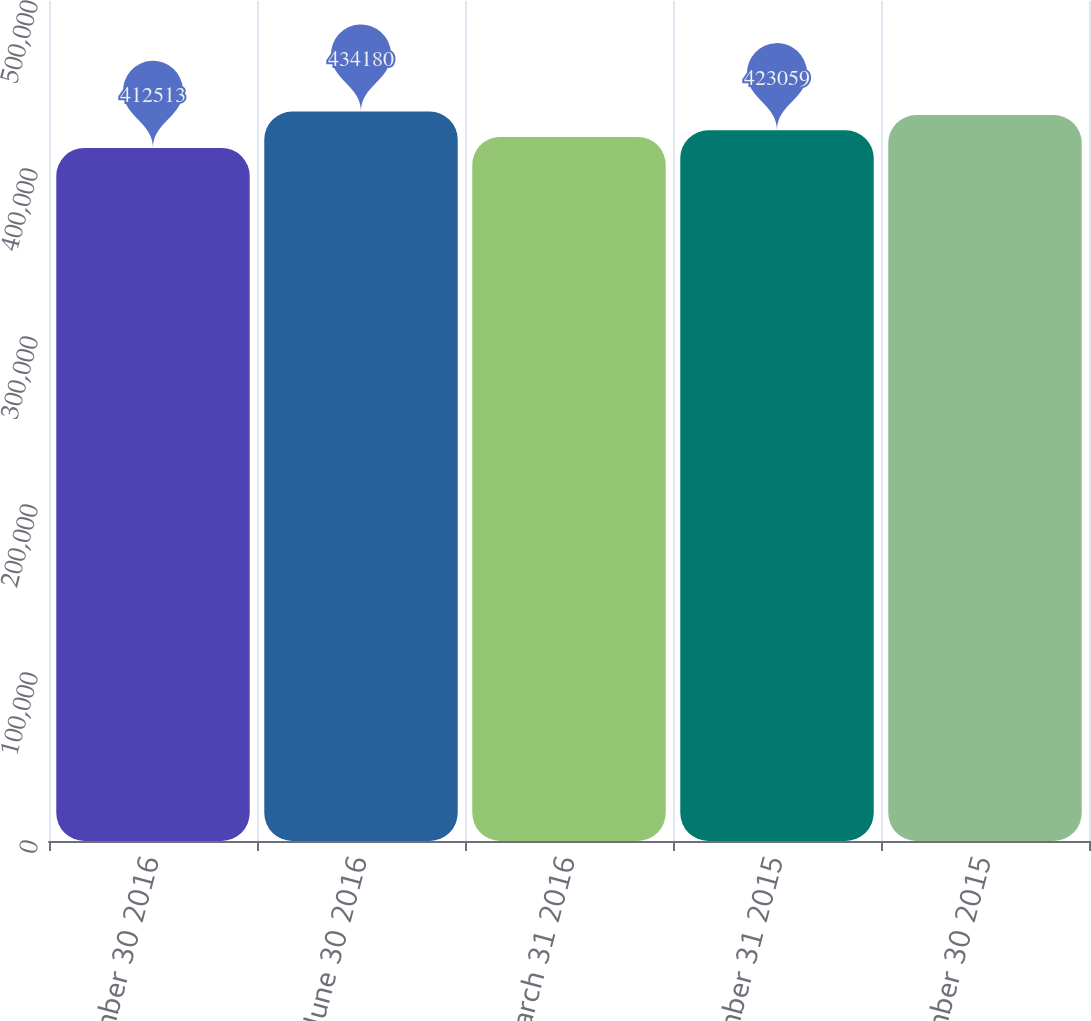Convert chart to OTSL. <chart><loc_0><loc_0><loc_500><loc_500><bar_chart><fcel>September 30 2016<fcel>June 30 2016<fcel>March 31 2016<fcel>December 31 2015<fcel>September 30 2015<nl><fcel>412513<fcel>434180<fcel>419112<fcel>423059<fcel>432131<nl></chart> 